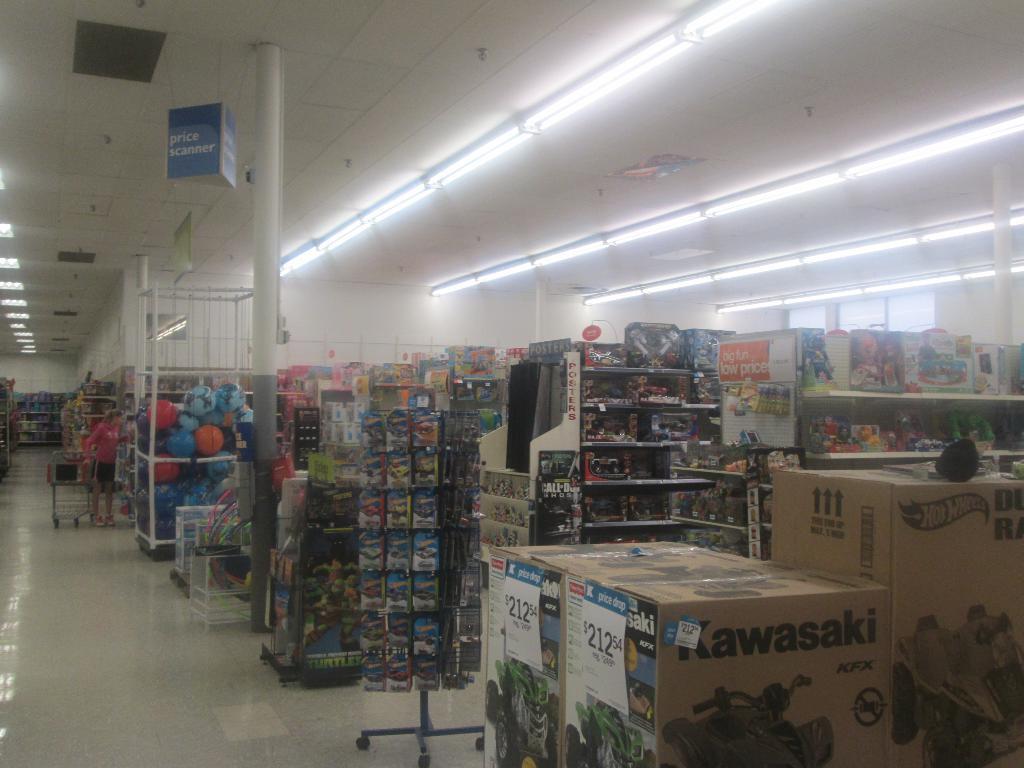Could you give a brief overview of what you see in this image? In this image, we can see a person and the ground. We can see some shelves with objects. We can see some poles and cardboard boxes with text and images on the right. We can also see the roof with some lights and objects. We can also see some metal objects. 